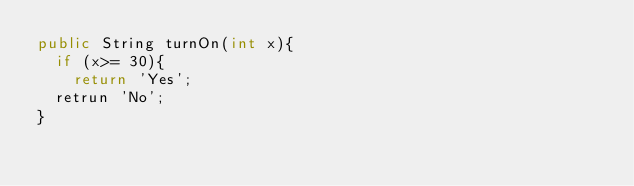<code> <loc_0><loc_0><loc_500><loc_500><_Java_>public String turnOn(int x){
  if (x>= 30){
    return 'Yes';
  retrun 'No';
}</code> 